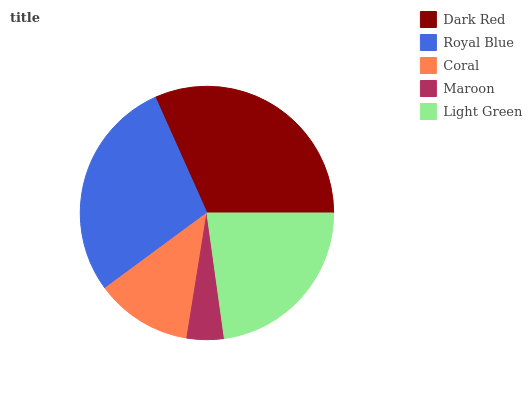Is Maroon the minimum?
Answer yes or no. Yes. Is Dark Red the maximum?
Answer yes or no. Yes. Is Royal Blue the minimum?
Answer yes or no. No. Is Royal Blue the maximum?
Answer yes or no. No. Is Dark Red greater than Royal Blue?
Answer yes or no. Yes. Is Royal Blue less than Dark Red?
Answer yes or no. Yes. Is Royal Blue greater than Dark Red?
Answer yes or no. No. Is Dark Red less than Royal Blue?
Answer yes or no. No. Is Light Green the high median?
Answer yes or no. Yes. Is Light Green the low median?
Answer yes or no. Yes. Is Royal Blue the high median?
Answer yes or no. No. Is Royal Blue the low median?
Answer yes or no. No. 